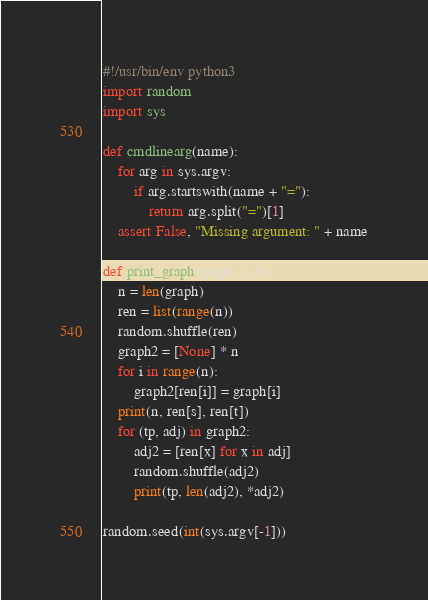Convert code to text. <code><loc_0><loc_0><loc_500><loc_500><_Python_>#!/usr/bin/env python3
import random
import sys

def cmdlinearg(name):
    for arg in sys.argv:
        if arg.startswith(name + "="):
            return arg.split("=")[1]
    assert False, "Missing argument: " + name

def print_graph(graph, s, t):
    n = len(graph)
    ren = list(range(n))
    random.shuffle(ren)
    graph2 = [None] * n
    for i in range(n):
        graph2[ren[i]] = graph[i]
    print(n, ren[s], ren[t])
    for (tp, adj) in graph2:
        adj2 = [ren[x] for x in adj]
        random.shuffle(adj2)
        print(tp, len(adj2), *adj2)

random.seed(int(sys.argv[-1]))
</code> 